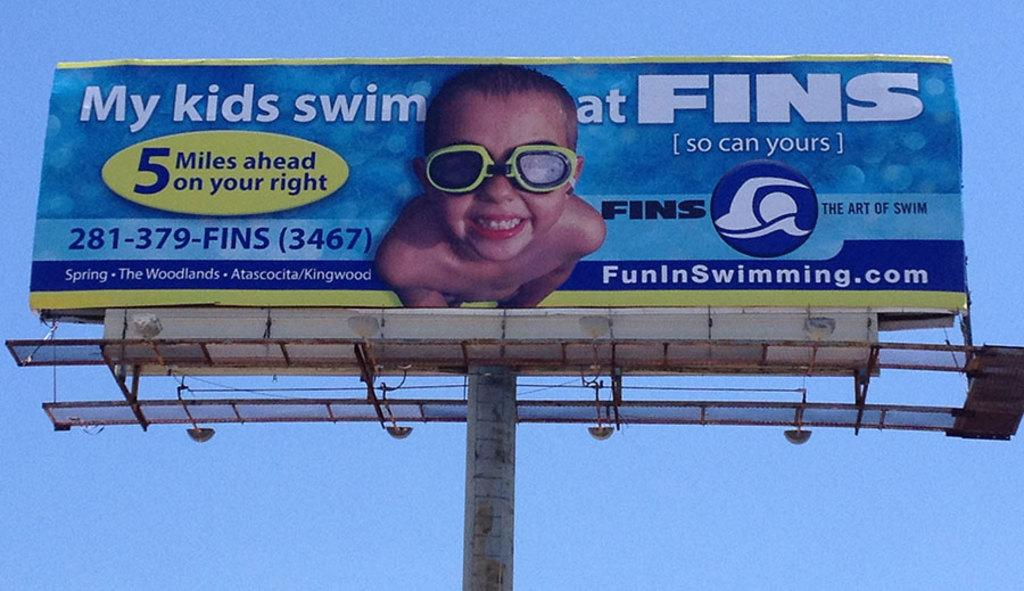Provide a one-sentence caption for the provided image. A giant billboard for Fins Swimming featuring a young boy. 